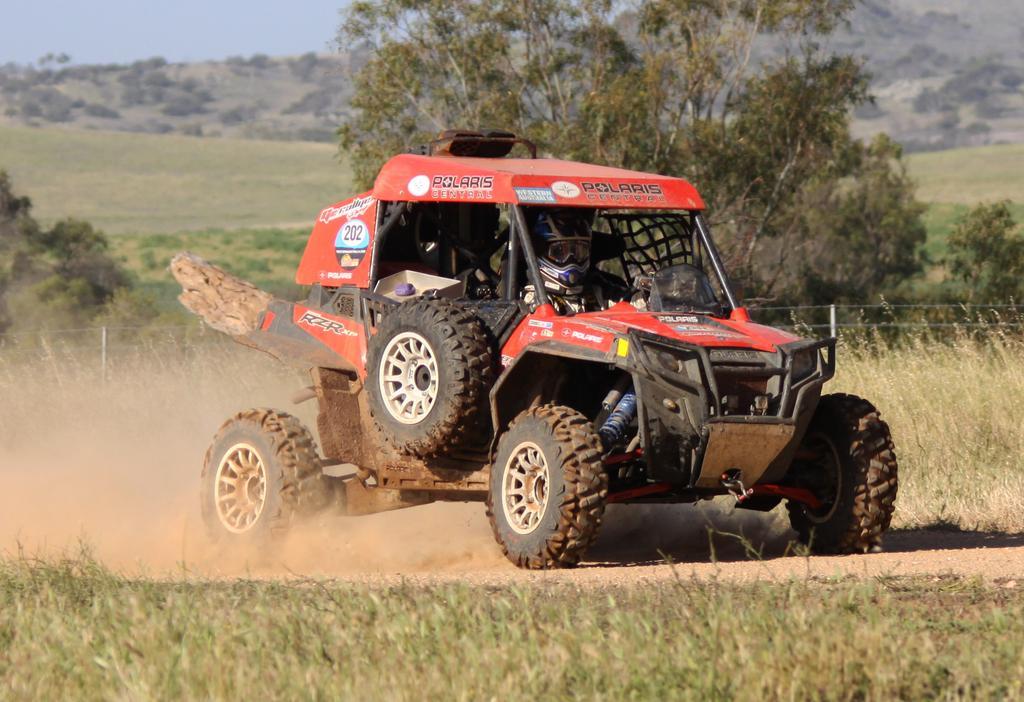Describe this image in one or two sentences. Here in this picture we can see a vehicle present on the ground and we can see a person sitting in it with helmet and goggles on him and we can see the ground is fully covered with grass and behind that we can see a log present and we can also see plants and trees present and in the far we can see mountains covered with plants that are in blurry manner and we can see the sky is cloudy. 